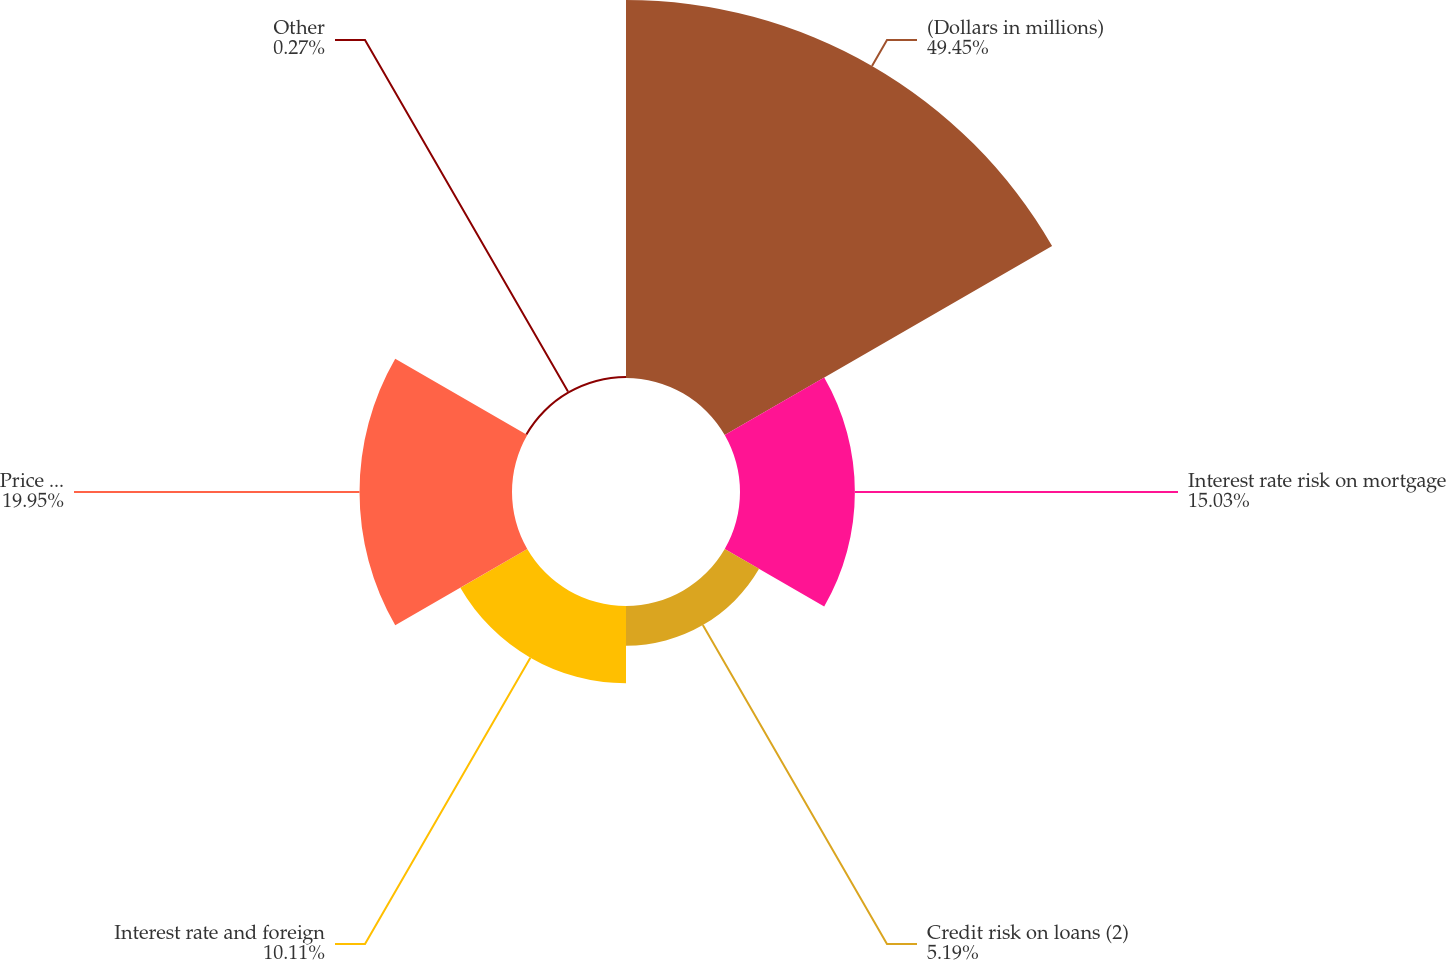<chart> <loc_0><loc_0><loc_500><loc_500><pie_chart><fcel>(Dollars in millions)<fcel>Interest rate risk on mortgage<fcel>Credit risk on loans (2)<fcel>Interest rate and foreign<fcel>Price risk on restricted stock<fcel>Other<nl><fcel>49.46%<fcel>15.03%<fcel>5.19%<fcel>10.11%<fcel>19.95%<fcel>0.27%<nl></chart> 